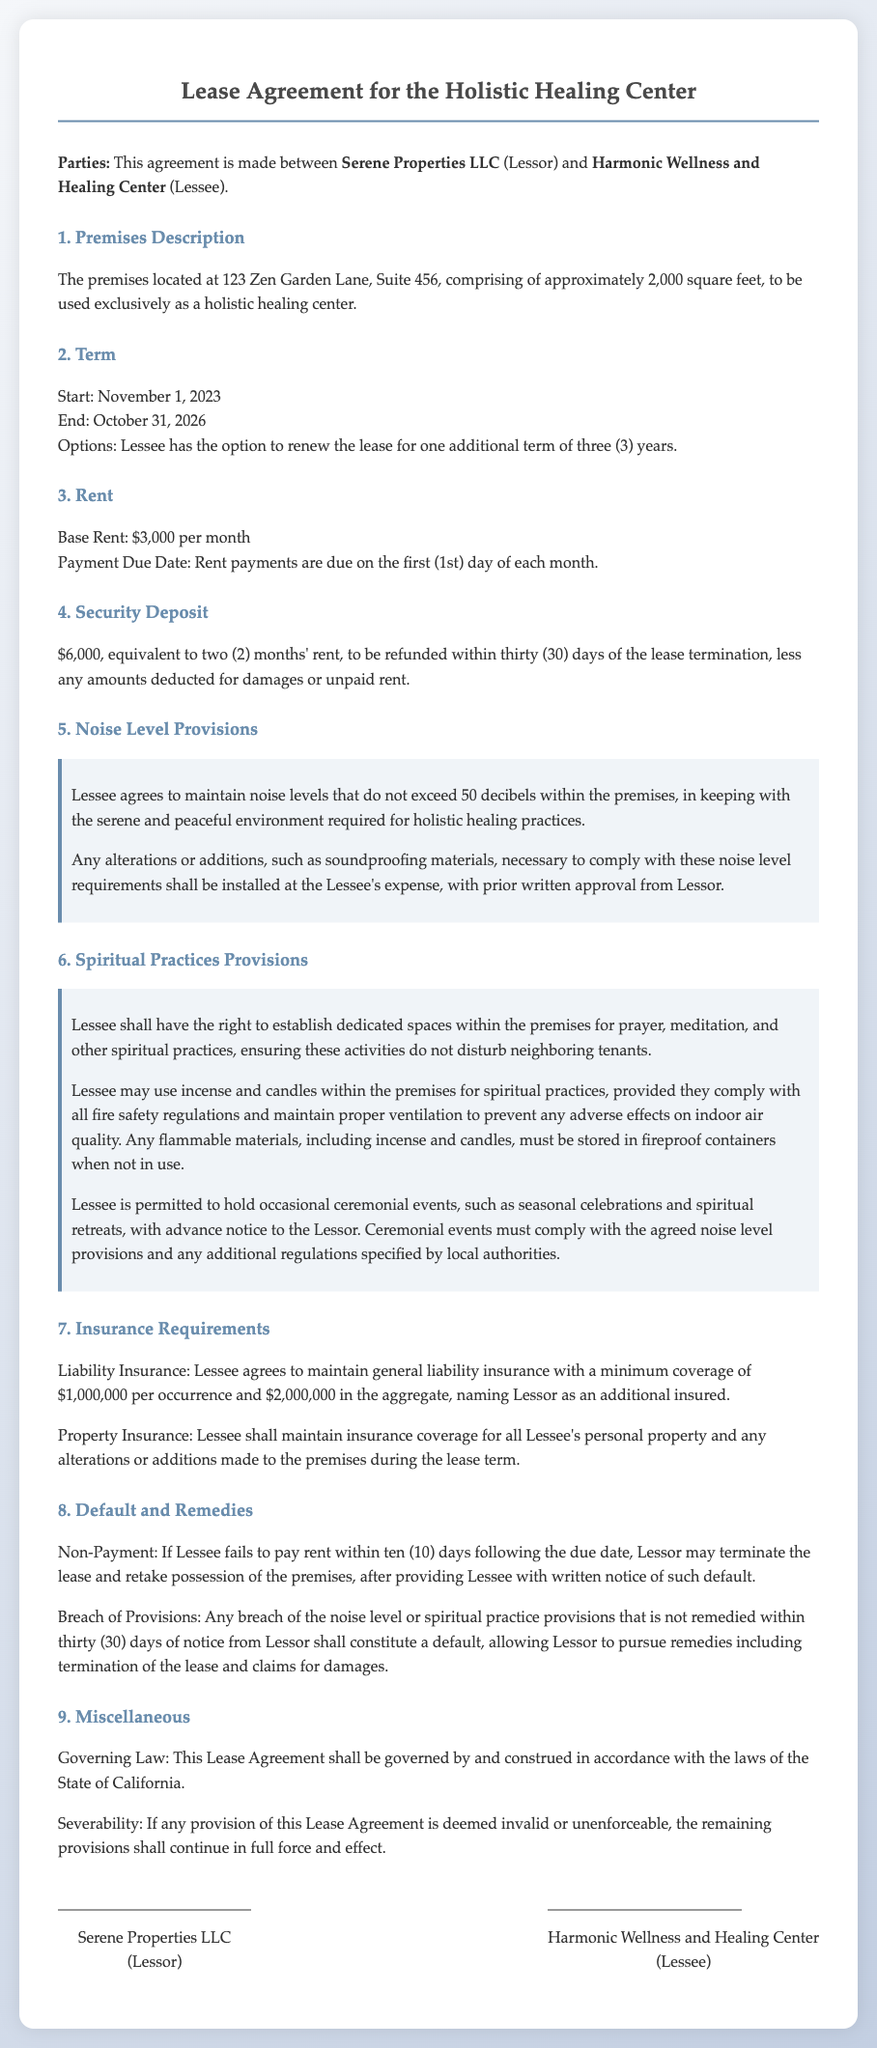What is the name of the Lessor? The Lessor is Serene Properties LLC, as stated in the introduction of the document.
Answer: Serene Properties LLC What is the total square footage of the premises? The premises is described as comprising approximately 2,000 square feet.
Answer: 2,000 square feet What is the base rent per month? The base rent specified in the document is $3,000 per month.
Answer: $3,000 What is the duration of the lease term? The lease term is specified to start on November 1, 2023, and end on October 31, 2026, which is a total of three years.
Answer: Three years What is the maximum noise level allowed in decibels? The maximum noise level that may not be exceeded within the premises is stated to be 50 decibels.
Answer: 50 decibels What coverage amount is required for liability insurance? The required minimum coverage for liability insurance is $1,000,000 per occurrence and $2,000,000 in the aggregate.
Answer: $1,000,000 per occurrence and $2,000,000 in the aggregate Who must give written approval for soundproofing materials? The written approval for soundproofing materials must be obtained from the Lessor, as mentioned in the noise level provisions.
Answer: Lessor What must the Lessee do if they wish to hold ceremonial events? The Lessee must provide advance notice to the Lessor for any ceremonial events they wish to hold.
Answer: Provide advance notice What happens if the Lessee breaches the provisions related to noise levels? If the Lessee breaches the noise level provisions and does not remedy it within thirty days, it shall constitute a default and may lead to lease termination.
Answer: Lease termination 